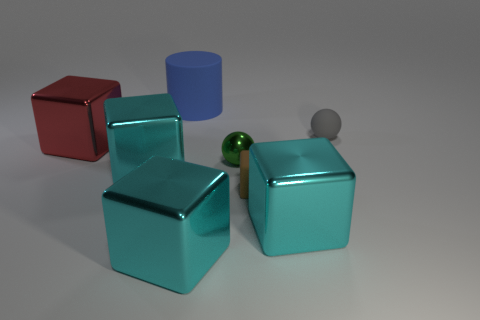Subtract all cyan cubes. How many were subtracted if there are1cyan cubes left? 2 Subtract all green cylinders. How many cyan cubes are left? 3 Subtract all green cubes. Subtract all cyan cylinders. How many cubes are left? 5 Add 1 tiny blue metal things. How many objects exist? 9 Subtract all cylinders. How many objects are left? 7 Subtract all blue rubber cylinders. Subtract all large red blocks. How many objects are left? 6 Add 2 small metallic spheres. How many small metallic spheres are left? 3 Add 4 small gray metal cubes. How many small gray metal cubes exist? 4 Subtract 0 yellow cubes. How many objects are left? 8 